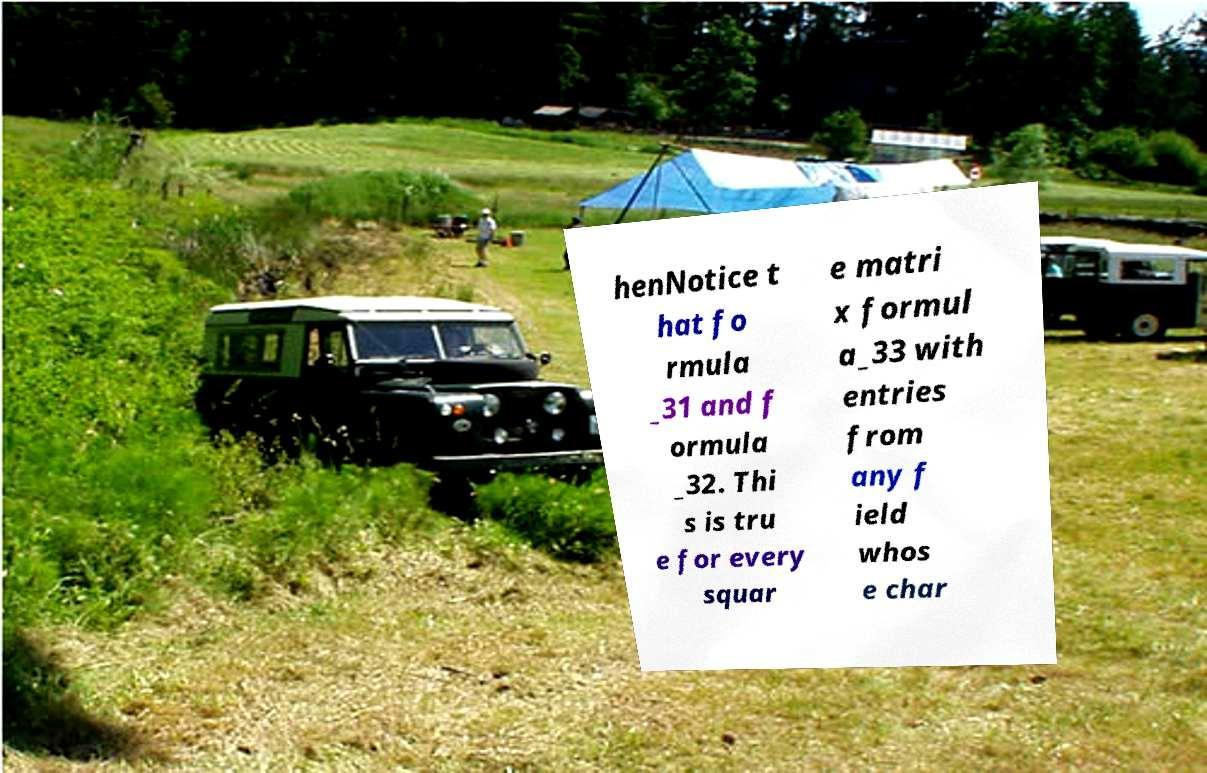Could you extract and type out the text from this image? henNotice t hat fo rmula _31 and f ormula _32. Thi s is tru e for every squar e matri x formul a_33 with entries from any f ield whos e char 